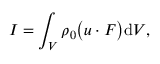<formula> <loc_0><loc_0><loc_500><loc_500>I = \int _ { V } \rho _ { 0 } \left ( u \cdot F \right ) d V ,</formula> 